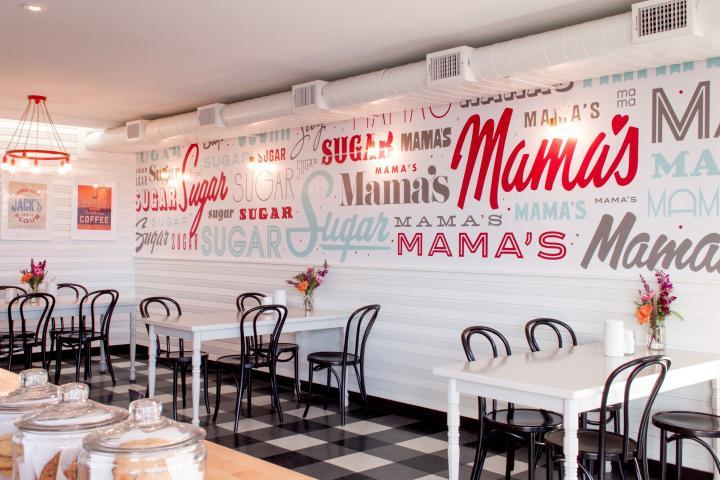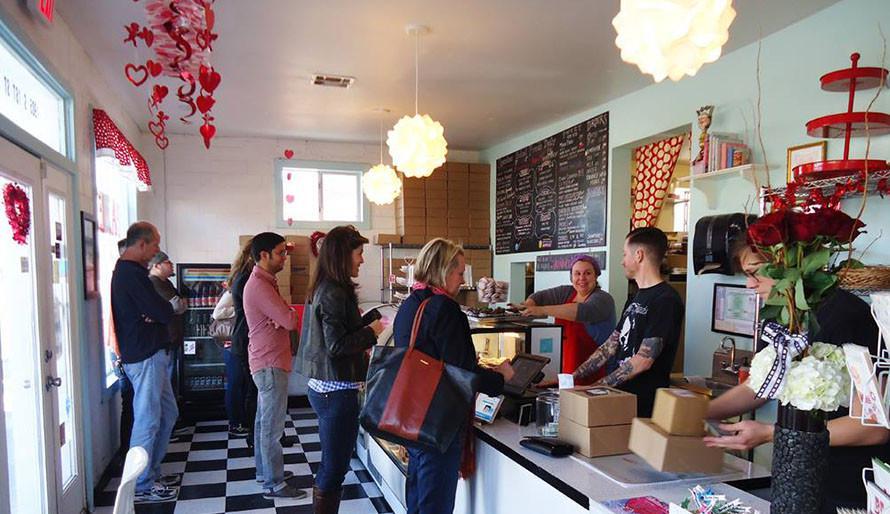The first image is the image on the left, the second image is the image on the right. Evaluate the accuracy of this statement regarding the images: "The left image is an interior featuring open-back black chairs around at least one white rectangular table on a black-and-white checkered floor.". Is it true? Answer yes or no. Yes. The first image is the image on the left, the second image is the image on the right. For the images displayed, is the sentence "In one image, a bakery has a seating area with black chairs and at least one white table." factually correct? Answer yes or no. Yes. 